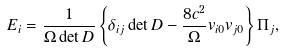Convert formula to latex. <formula><loc_0><loc_0><loc_500><loc_500>E _ { i } = \frac { 1 } { \Omega \det D } \left \{ { \delta _ { i j } \det D - \frac { 8 c ^ { 2 } } { \Omega } v _ { i 0 } v _ { j 0 } } \right \} \Pi _ { j } ,</formula> 